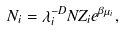Convert formula to latex. <formula><loc_0><loc_0><loc_500><loc_500>N _ { i } = \lambda _ { i } ^ { - D } N Z _ { i } e ^ { \beta \mu _ { i } } ,</formula> 